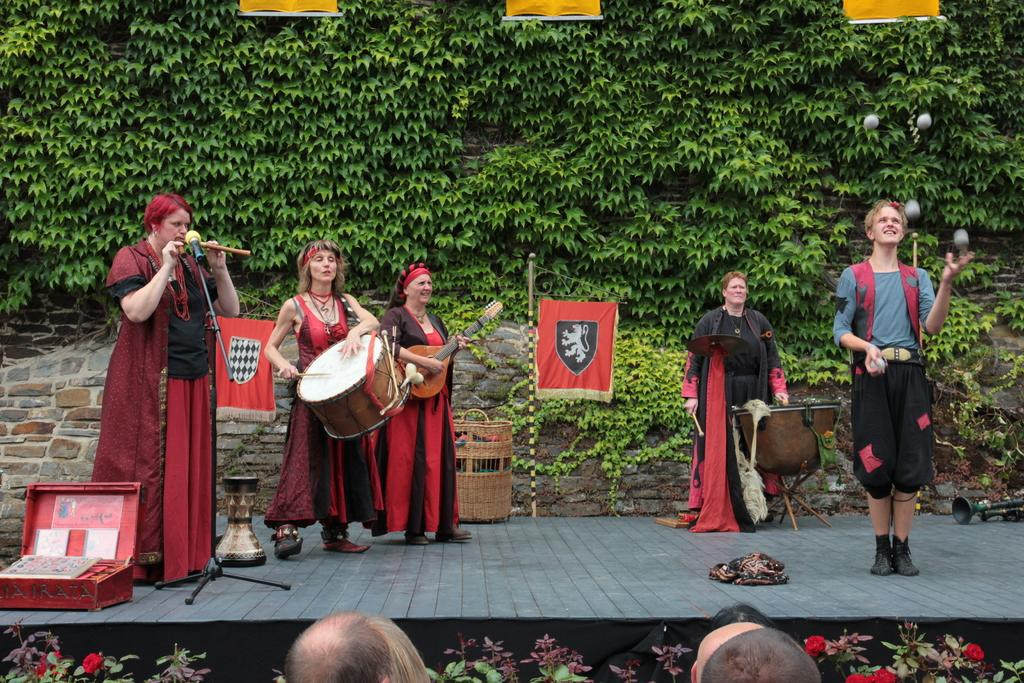Who or what can be seen in the image? There are people in the image. What are the people doing in the image? The people are standing in the image. What are the people holding in their hands? The people are holding music instruments in their hands. Where is the pet hydrant located in the wilderness? There is no pet hydrant or wilderness present in the image. 